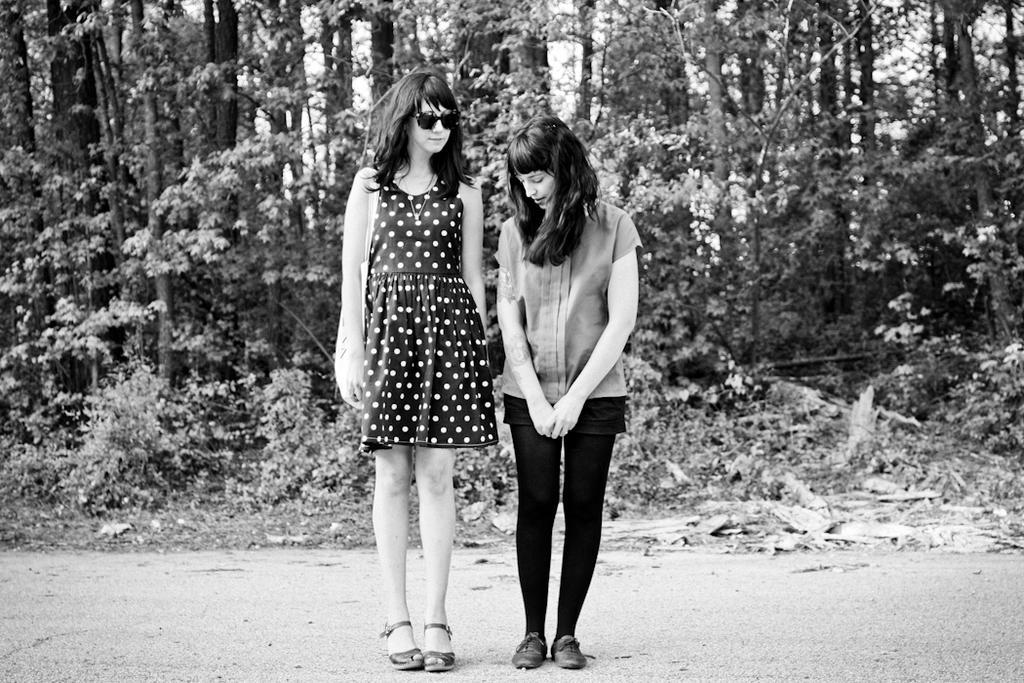How would you summarize this image in a sentence or two? This is a black and white picture. Here we can see two women are standing on the road. In the background we can see plants and trees. 